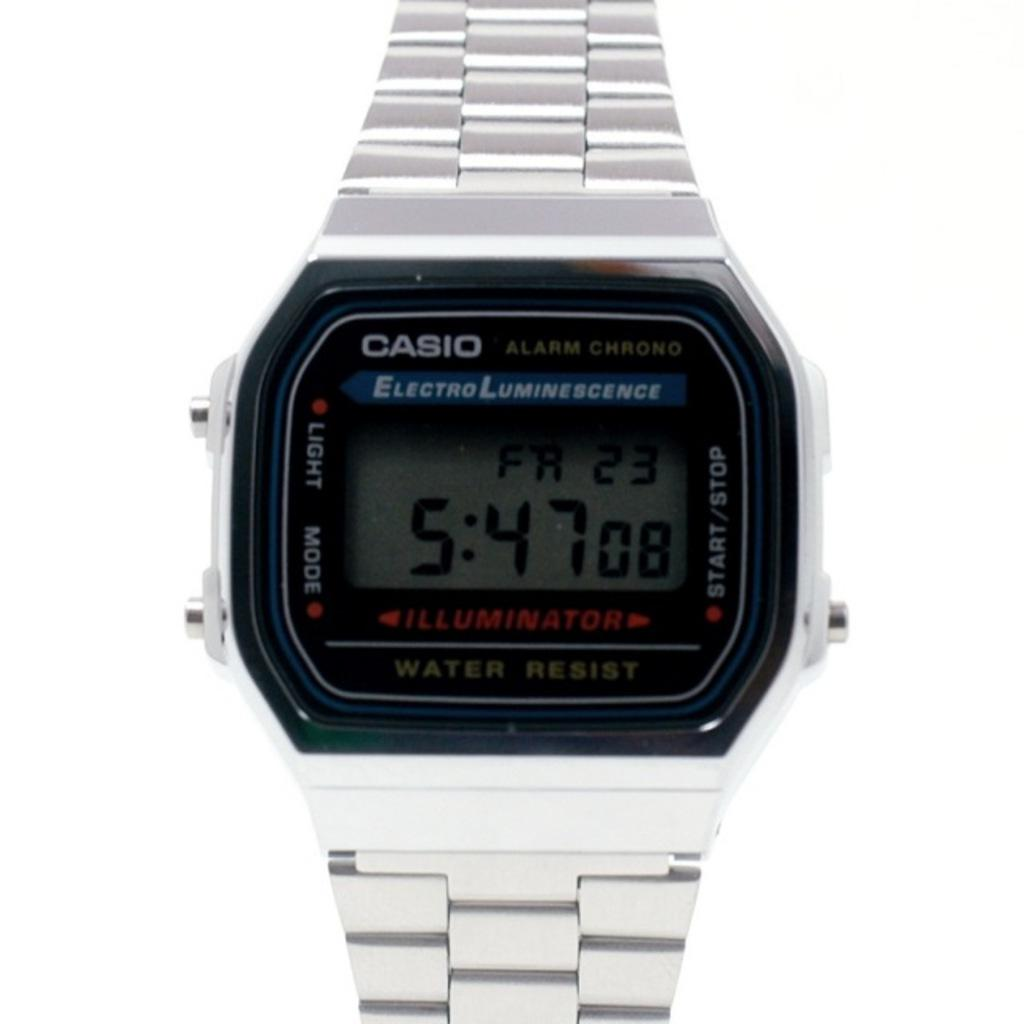What object is the main focus of the image? There is a watch in the image. What can be seen on the glass of the watch? There is text and numbers on the glass of the watch. What color is the background of the image? The background of the image is white. How much cheese is on the brake in the image? There is no cheese or brake present in the image; it features a watch with text and numbers on the glass against a white background. 